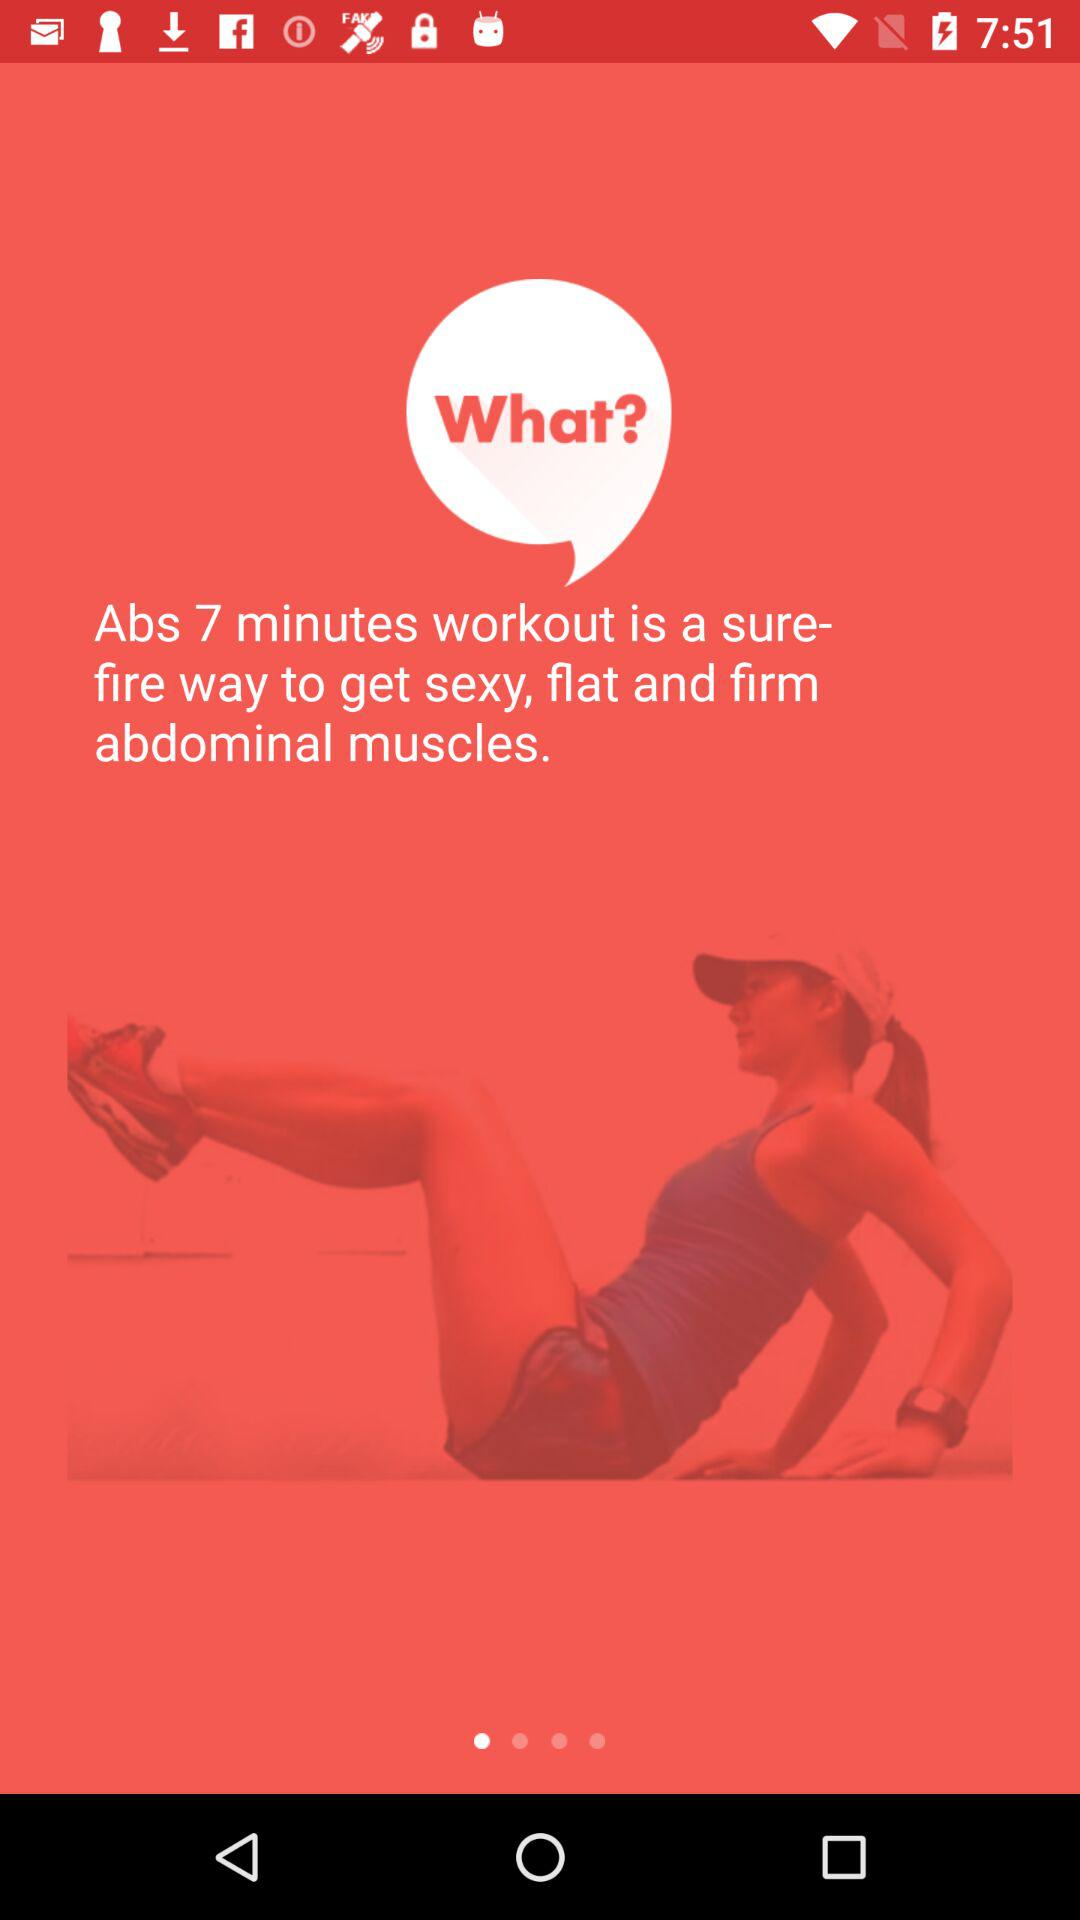How many minutes does it take to get firm arm muscles?
When the provided information is insufficient, respond with <no answer>. <no answer> 